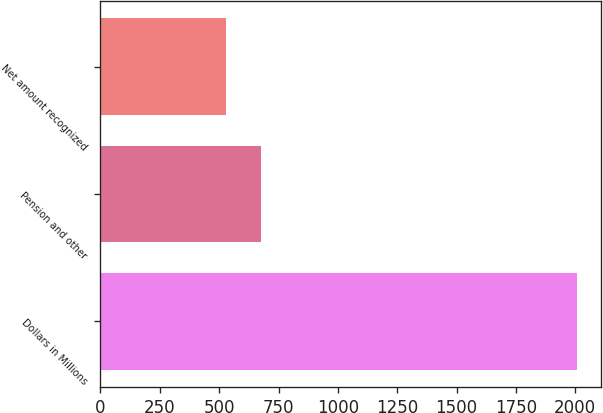Convert chart. <chart><loc_0><loc_0><loc_500><loc_500><bar_chart><fcel>Dollars in Millions<fcel>Pension and other<fcel>Net amount recognized<nl><fcel>2006<fcel>675.8<fcel>528<nl></chart> 